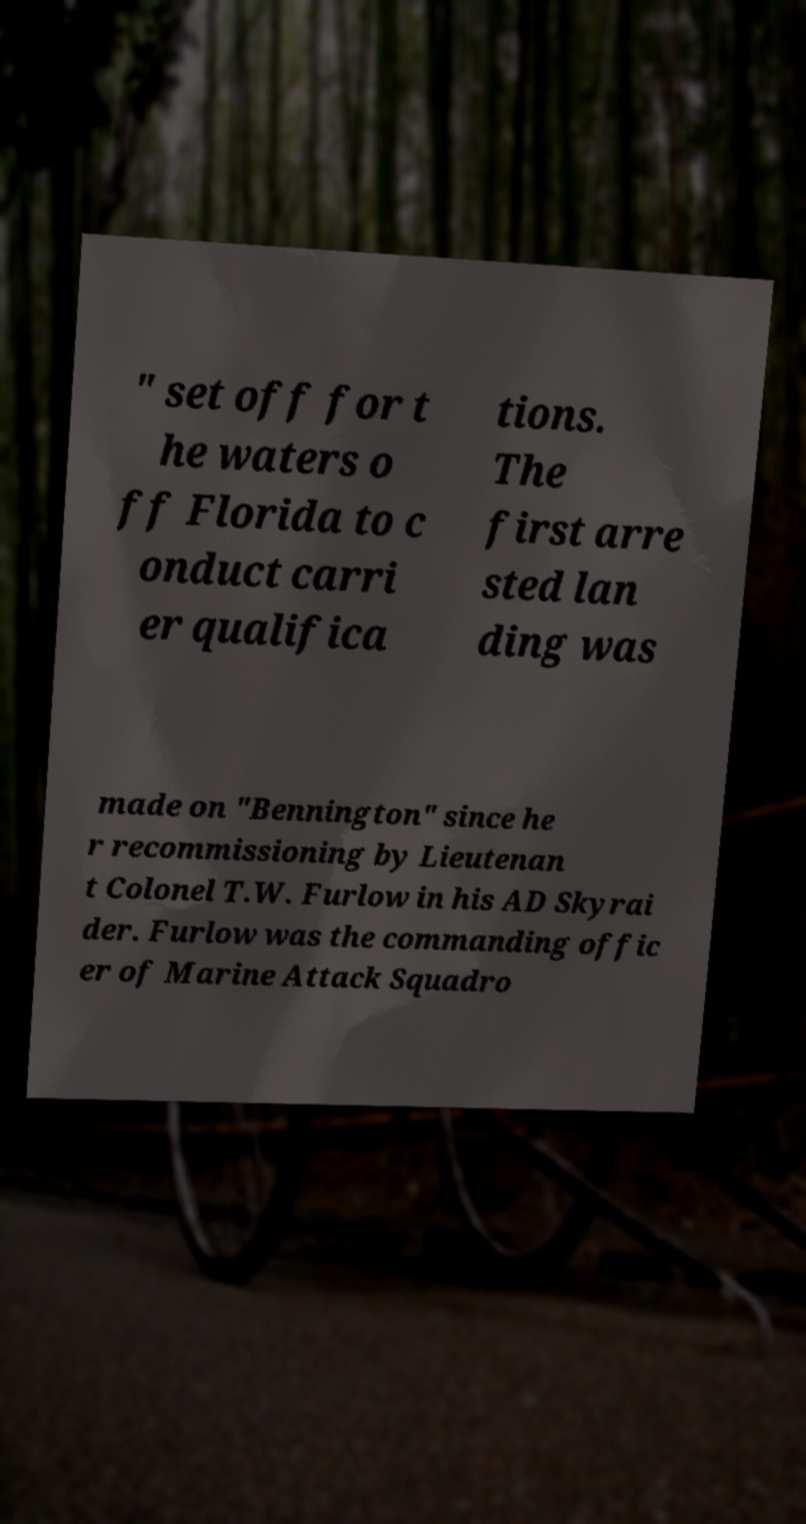I need the written content from this picture converted into text. Can you do that? " set off for t he waters o ff Florida to c onduct carri er qualifica tions. The first arre sted lan ding was made on "Bennington" since he r recommissioning by Lieutenan t Colonel T.W. Furlow in his AD Skyrai der. Furlow was the commanding offic er of Marine Attack Squadro 